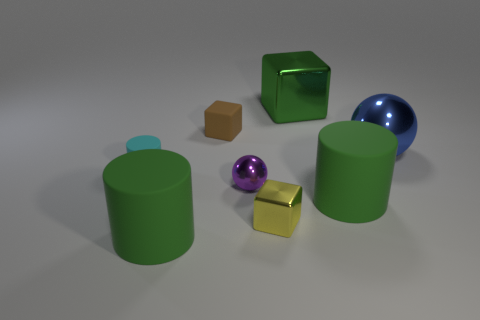What number of rubber cubes have the same size as the yellow metallic thing? One of the rubber cubes is of the same size as the yellow metallic cube in the image. 